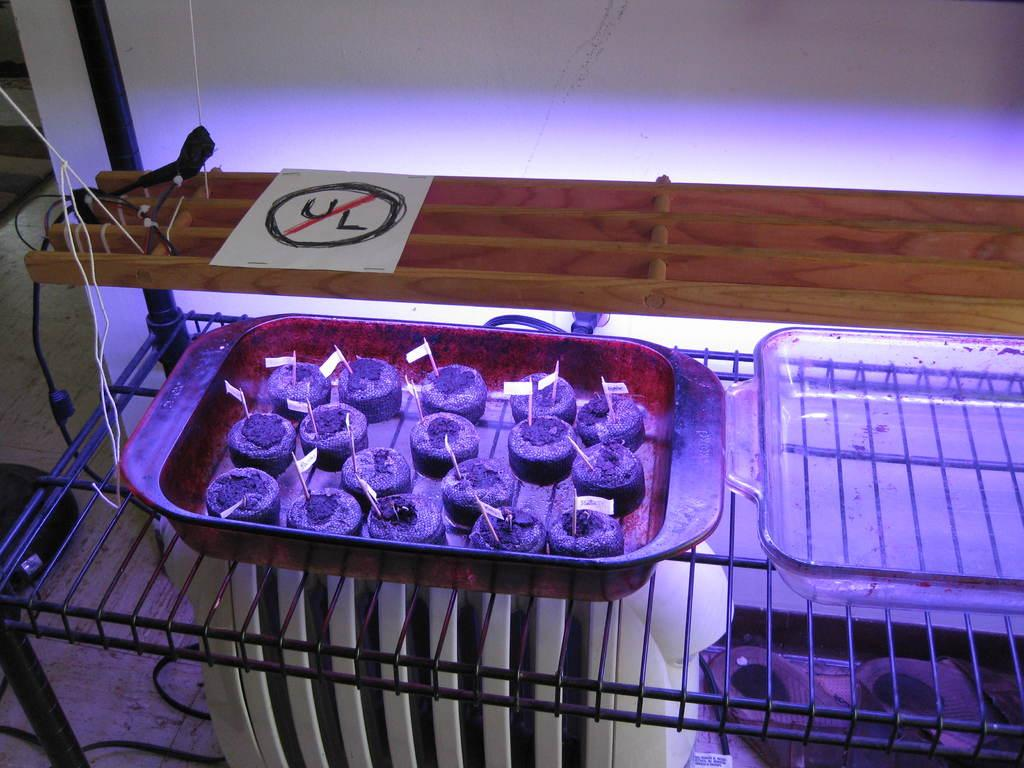Provide a one-sentence caption for the provided image. A non UL approved lighting fixture above some plant seedlings. 